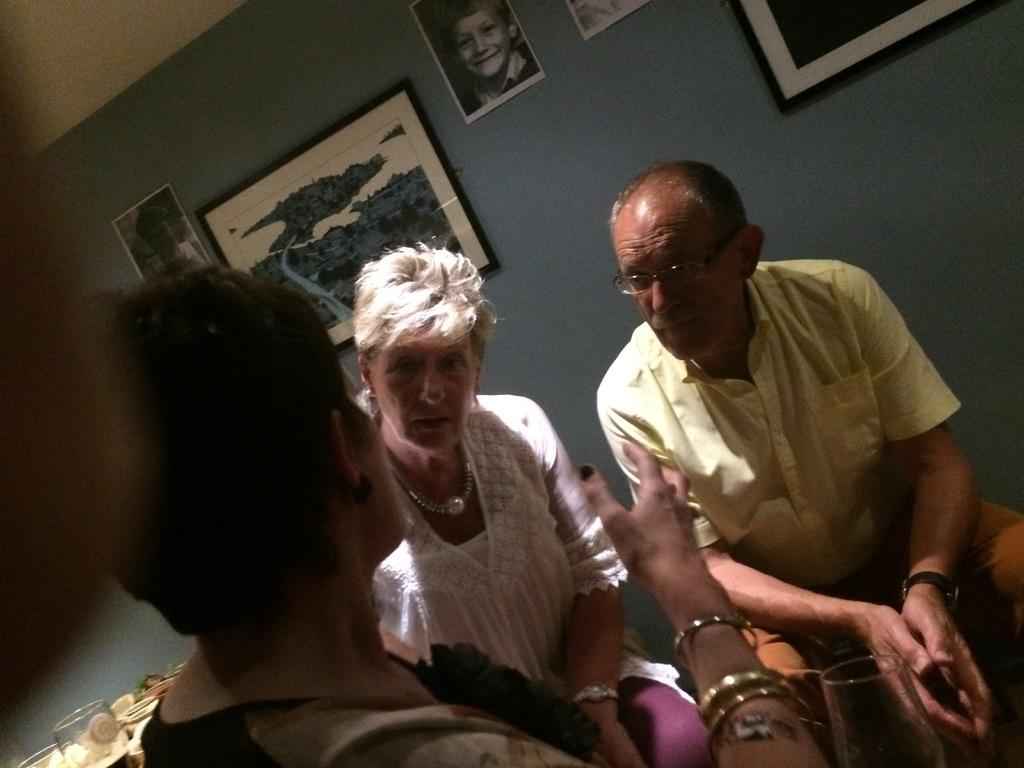How many people are in the image? There are three persons in the image. What objects can be seen in the image besides the people? There are glasses and unspecified objects in the image. What can be seen in the background of the image? There is a wall, frames, and photographs in the background of the image. What type of drum can be heard in the image? There is no drum present in the image, so it is not possible to hear any drum sounds. 